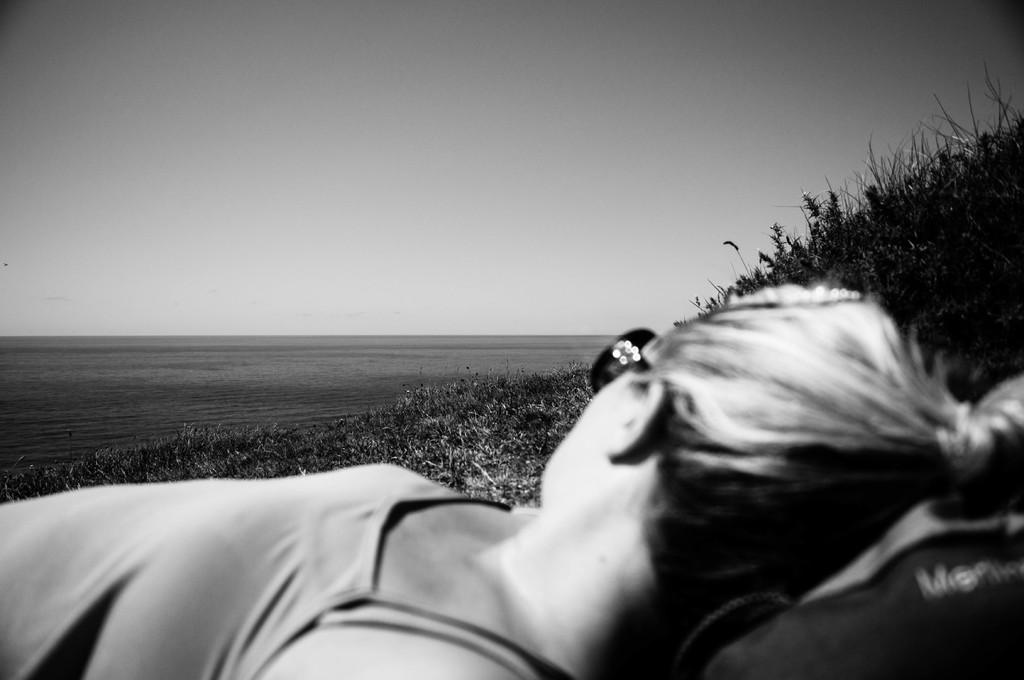Who is present in the image? There is a woman in the image. What is the woman wearing? The woman is wearing sunglasses. What is the woman's position in the image? The woman is lying on the grass. What can be seen in the background of the image? There is sea water visible in the background of the image. What type of wrench is the woman using to measure the distance between the rocks in the image? There is no wrench present in the image, and the woman is not measuring any distances. 